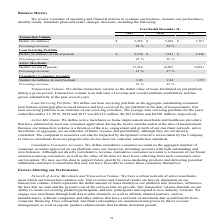According to Greensky's financial document, How did the company define Active Merchants? home improvement merchants and healthcare providers that have submitted at least one consumer application during the twelve months ended at the date of measurement. The document states: "Active Merchants. We define active merchants as home improvement merchants and healthcare providers that have submitted at least one consumer applicat..." Also, How did the company define Loan Servicing Portfolio? the aggregate outstanding consumer loan balance (principal plus accrued interest and fees) serviced by our platform at the date of measurement.. The document states: "rtfolio. We define our loan servicing portfolio as the aggregate outstanding consumer loan balance (principal plus accrued interest and fees) serviced..." Also, What was the transaction volume in 2019? According to the financial document, 5,954 (in millions). The relevant text states: "8 2017 Transaction Volume Dollars (in millions) $ 5,954 $ 5,030 $ 3,767..." Also, How many years did the Transaction volume exceed $5,000 million? Counting the relevant items in the document: 2019, 2018, I find 2 instances. The key data points involved are: 2018, 2019. Also, can you calculate: What was the change in the Loan Servicing Portfolio between 2017 and 2018? Based on the calculation: 7,341-5,390, the result is 1951 (in millions). This is based on the information: "(in millions, at end of period) $ 9,150 $ 7,341 $ 5,390 Percentage increase 25 % 36 % Active Merchants Number (at end of period) 17,216 14,907 10,891 Perce Dollars (in millions, at end of period) $ 9,..." The key data points involved are: 5,390, 7,341. Also, can you calculate: What was the percentage change in the Cumulative Consumer Accounts between 2017 and 2019? To answer this question, I need to perform calculations using the financial data. The calculation is: (3.03-1.57)/1.57, which equals 92.99 (percentage). This is based on the information: "Number (in millions, at end of period) 3.03 2.24 1.57 Percentage increase 35 % 43 % r Accounts Number (in millions, at end of period) 3.03 2.24 1.57 Percentage increase 35 % 43 %..." The key data points involved are: 1.57, 3.03. 